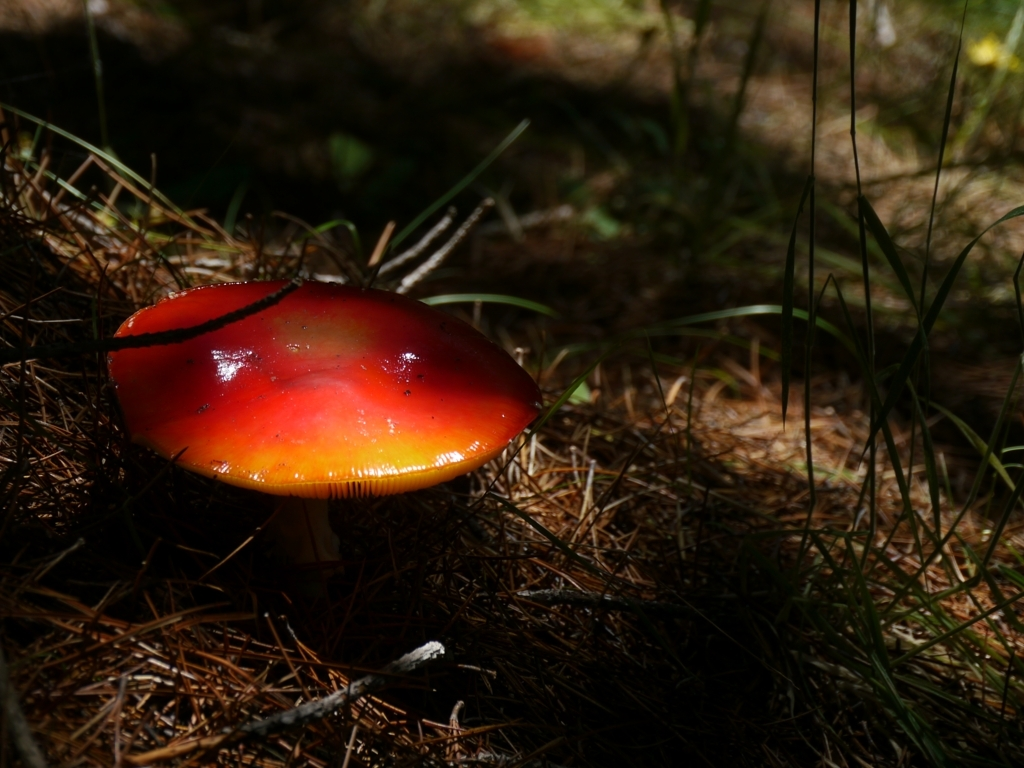Could you explain the significance of the lighting in this image? The lighting in this image plays a dramatic role in highlighting the mushroom. A shaft of light illuminates the mushroom's cap, making it appear almost luminescent against the shadowed backdrop. This selective lighting creates a spotlight effect and adds visual interest, drawing the viewer's attention to the subject. It also enhances the texture and color of the mushroom, contributing to the overall aesthetic of the photograph. 